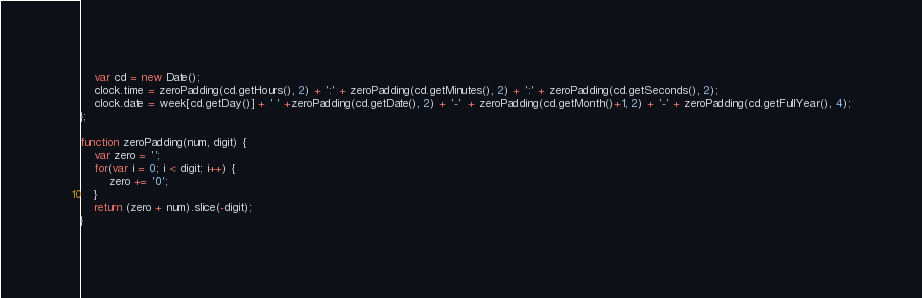<code> <loc_0><loc_0><loc_500><loc_500><_JavaScript_>    var cd = new Date();
    clock.time = zeroPadding(cd.getHours(), 2) + ':' + zeroPadding(cd.getMinutes(), 2) + ':' + zeroPadding(cd.getSeconds(), 2);
    clock.date = week[cd.getDay()] + ' ' +zeroPadding(cd.getDate(), 2) + '-'  + zeroPadding(cd.getMonth()+1, 2) + '-' + zeroPadding(cd.getFullYear(), 4);
};

function zeroPadding(num, digit) {
    var zero = '';
    for(var i = 0; i < digit; i++) {
        zero += '0';
    }
    return (zero + num).slice(-digit);
}</code> 